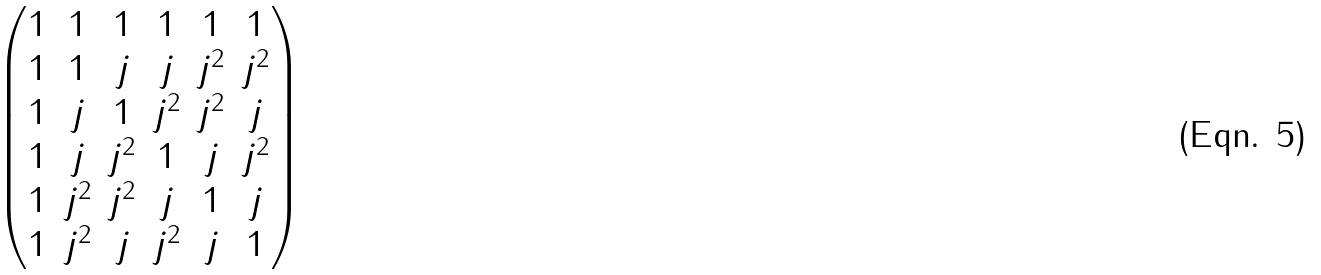<formula> <loc_0><loc_0><loc_500><loc_500>\begin{pmatrix} 1 & 1 & 1 & 1 & 1 & 1 \\ 1 & 1 & j & j & j ^ { 2 } & j ^ { 2 } \\ 1 & j & 1 & j ^ { 2 } & j ^ { 2 } & j \\ 1 & j & j ^ { 2 } & 1 & j & j ^ { 2 } \\ 1 & j ^ { 2 } & j ^ { 2 } & j & 1 & j \\ 1 & j ^ { 2 } & j & j ^ { 2 } & j & 1 \end{pmatrix}</formula> 